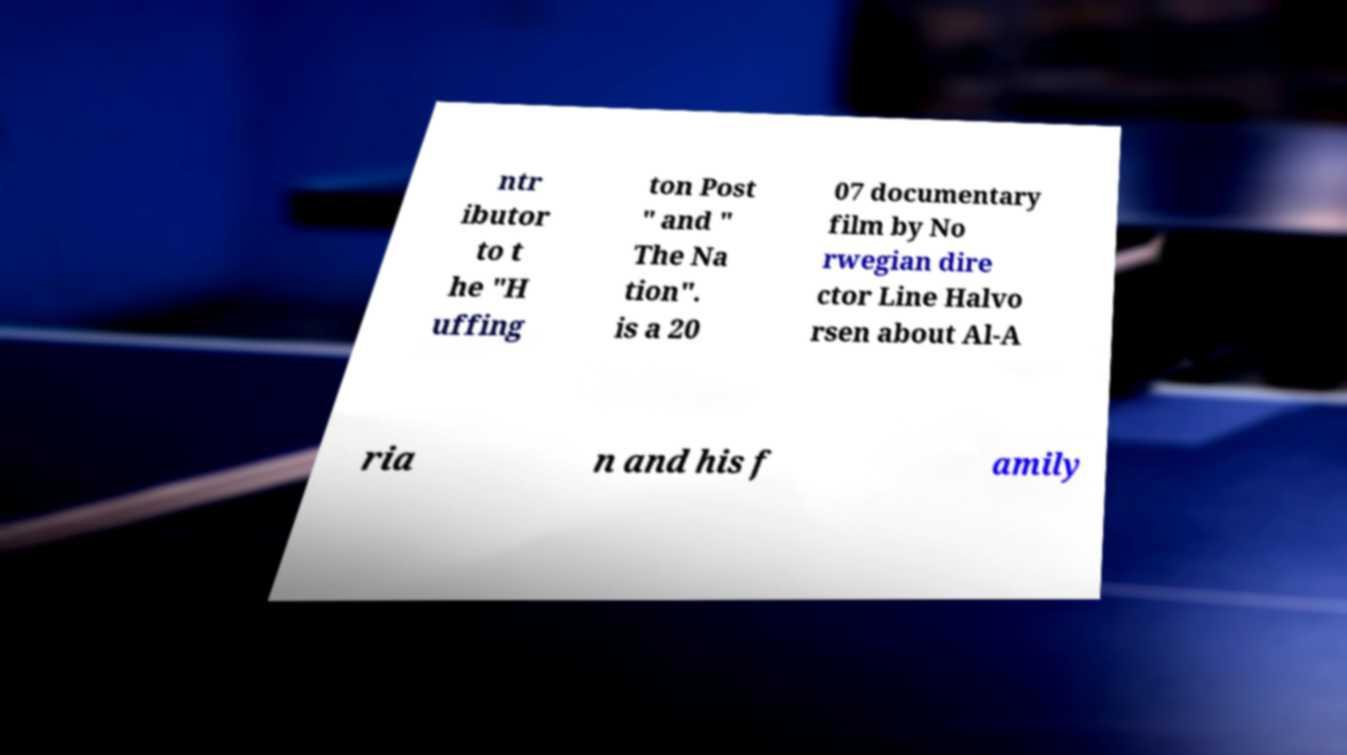I need the written content from this picture converted into text. Can you do that? ntr ibutor to t he "H uffing ton Post " and " The Na tion". is a 20 07 documentary film by No rwegian dire ctor Line Halvo rsen about Al-A ria n and his f amily 